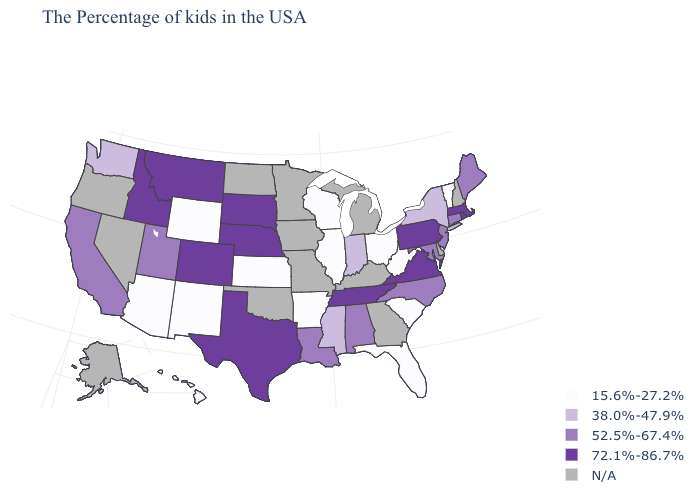What is the highest value in the USA?
Keep it brief. 72.1%-86.7%. What is the value of New Hampshire?
Concise answer only. N/A. Name the states that have a value in the range N/A?
Answer briefly. New Hampshire, Delaware, Georgia, Michigan, Kentucky, Missouri, Minnesota, Iowa, Oklahoma, North Dakota, Nevada, Oregon, Alaska. What is the lowest value in states that border Maryland?
Concise answer only. 15.6%-27.2%. Does the map have missing data?
Short answer required. Yes. Is the legend a continuous bar?
Be succinct. No. What is the lowest value in the Northeast?
Quick response, please. 15.6%-27.2%. What is the highest value in the USA?
Be succinct. 72.1%-86.7%. Does the map have missing data?
Concise answer only. Yes. What is the lowest value in the Northeast?
Concise answer only. 15.6%-27.2%. What is the value of Washington?
Keep it brief. 38.0%-47.9%. Name the states that have a value in the range 52.5%-67.4%?
Be succinct. Maine, Connecticut, New Jersey, Maryland, North Carolina, Alabama, Louisiana, Utah, California. 